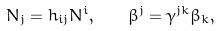Convert formula to latex. <formula><loc_0><loc_0><loc_500><loc_500>N _ { j } = h _ { i j } N ^ { i } , \quad \beta ^ { j } = \gamma ^ { j k } \beta _ { k } ,</formula> 